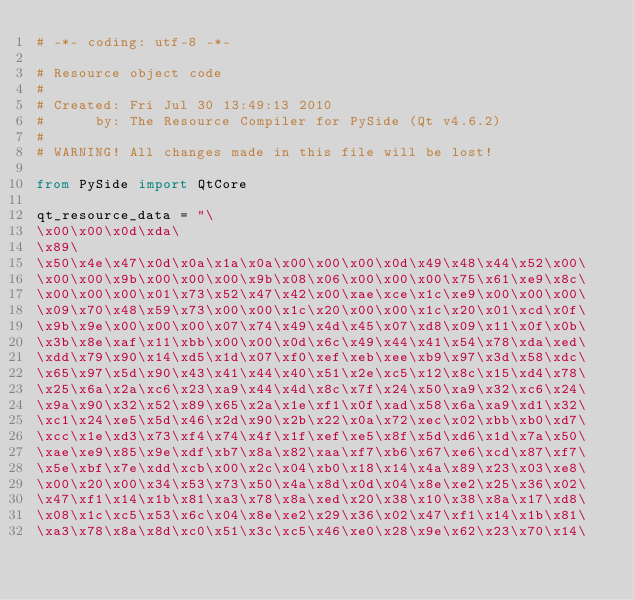<code> <loc_0><loc_0><loc_500><loc_500><_Python_># -*- coding: utf-8 -*-

# Resource object code
#
# Created: Fri Jul 30 13:49:13 2010
#      by: The Resource Compiler for PySide (Qt v4.6.2)
#
# WARNING! All changes made in this file will be lost!

from PySide import QtCore

qt_resource_data = "\
\x00\x00\x0d\xda\
\x89\
\x50\x4e\x47\x0d\x0a\x1a\x0a\x00\x00\x00\x0d\x49\x48\x44\x52\x00\
\x00\x00\x9b\x00\x00\x00\x9b\x08\x06\x00\x00\x00\x75\x61\xe9\x8c\
\x00\x00\x00\x01\x73\x52\x47\x42\x00\xae\xce\x1c\xe9\x00\x00\x00\
\x09\x70\x48\x59\x73\x00\x00\x1c\x20\x00\x00\x1c\x20\x01\xcd\x0f\
\x9b\x9e\x00\x00\x00\x07\x74\x49\x4d\x45\x07\xd8\x09\x11\x0f\x0b\
\x3b\x8e\xaf\x11\xbb\x00\x00\x0d\x6c\x49\x44\x41\x54\x78\xda\xed\
\xdd\x79\x90\x14\xd5\x1d\x07\xf0\xef\xeb\xee\xb9\x97\x3d\x58\xdc\
\x65\x97\x5d\x90\x43\x41\x44\x40\x51\x2e\xc5\x12\x8c\x15\xd4\x78\
\x25\x6a\x2a\xc6\x23\xa9\x44\x4d\x8c\x7f\x24\x50\xa9\x32\xc6\x24\
\x9a\x90\x32\x52\x89\x65\x2a\x1e\xf1\x0f\xad\x58\x6a\xa9\xd1\x32\
\xc1\x24\xe5\x5d\x46\x2d\x90\x2b\x22\x0a\x72\xec\x02\xbb\xb0\xd7\
\xcc\x1e\xd3\x73\xf4\x74\x4f\x1f\xef\xe5\x8f\x5d\xd6\x1d\x7a\x50\
\xae\xe9\x85\x9e\xdf\xb7\x8a\x82\xaa\xf7\xb6\x67\xe6\xcd\x87\xf7\
\x5e\xbf\x7e\xdd\xcb\x00\x2c\x04\xb0\x18\x14\x4a\x89\x23\x03\xe8\
\x00\x20\x00\x34\x53\x73\x50\x4a\x8d\x0d\x04\x8e\xe2\x25\x36\x02\
\x47\xf1\x14\x1b\x81\xa3\x78\x8a\xed\x20\x38\x10\x38\x8a\x17\xd8\
\x08\x1c\xc5\x53\x6c\x04\x8e\xe2\x29\x36\x02\x47\xf1\x14\x1b\x81\
\xa3\x78\x8a\x8d\xc0\x51\x3c\xc5\x46\xe0\x28\x9e\x62\x23\x70\x14\</code> 